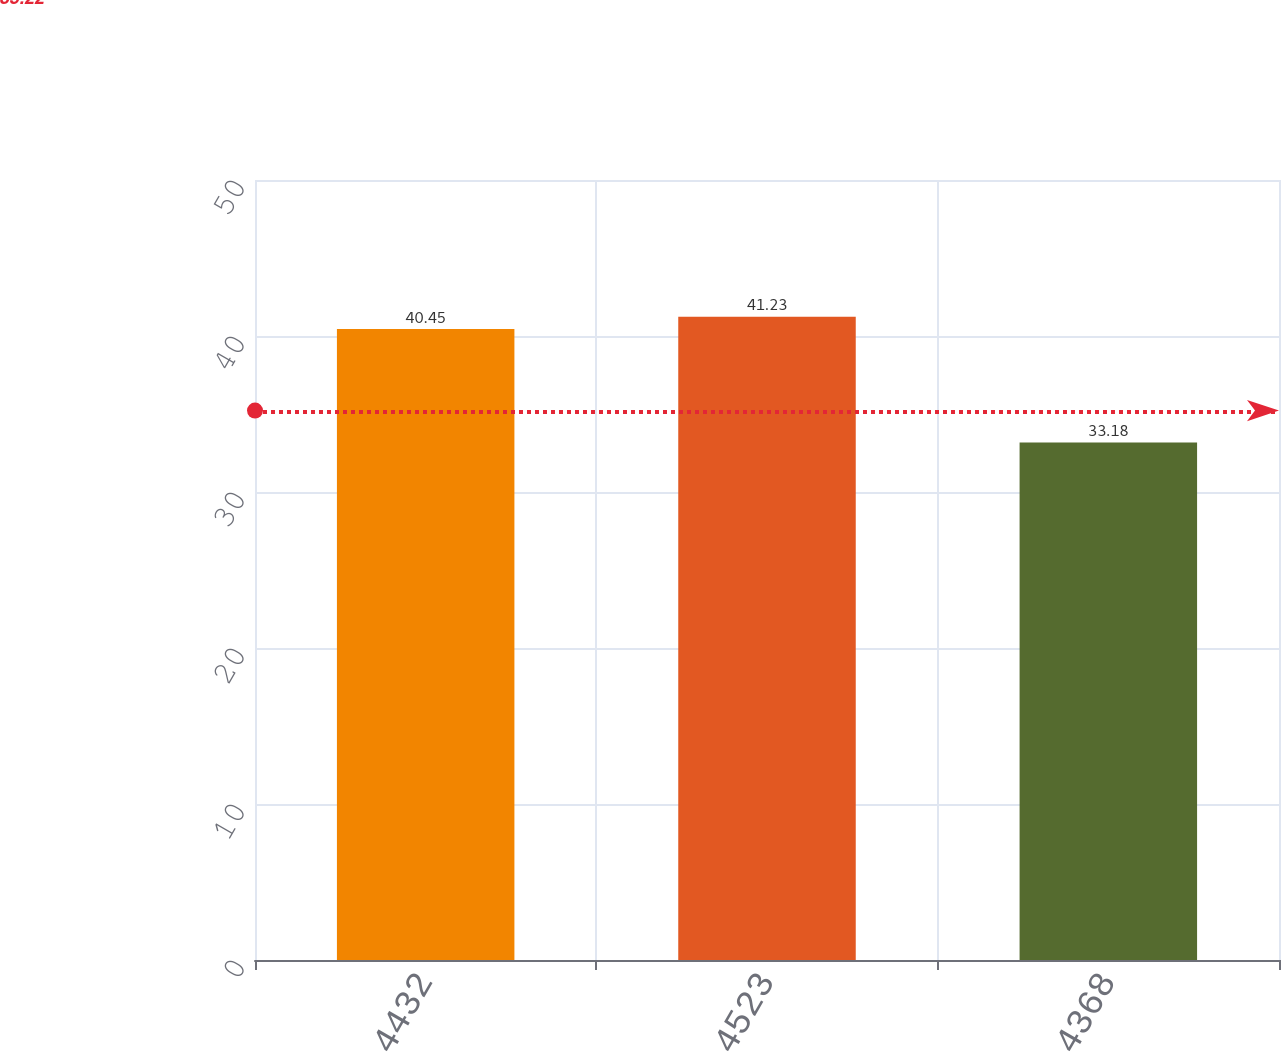<chart> <loc_0><loc_0><loc_500><loc_500><bar_chart><fcel>4432<fcel>4523<fcel>4368<nl><fcel>40.45<fcel>41.23<fcel>33.18<nl></chart> 